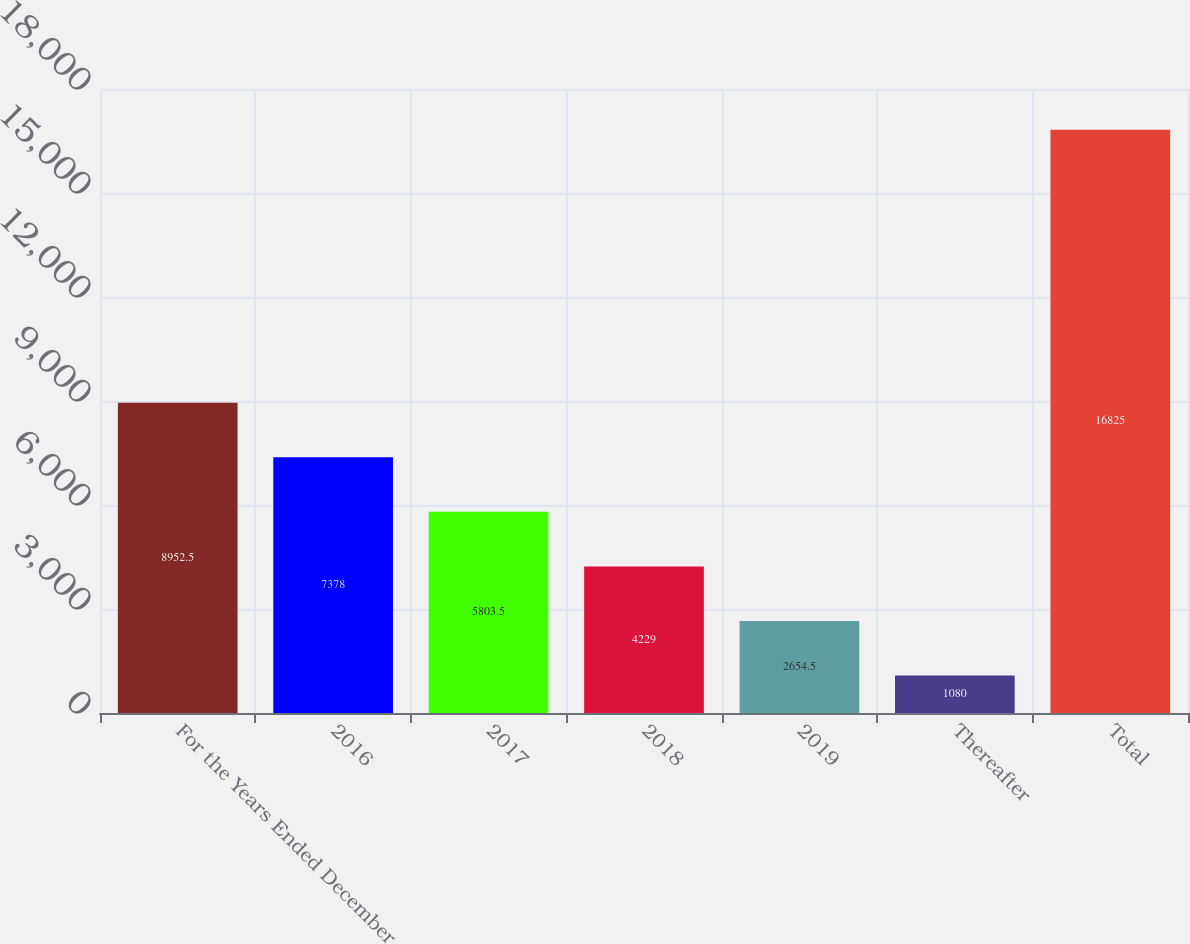<chart> <loc_0><loc_0><loc_500><loc_500><bar_chart><fcel>For the Years Ended December<fcel>2016<fcel>2017<fcel>2018<fcel>2019<fcel>Thereafter<fcel>Total<nl><fcel>8952.5<fcel>7378<fcel>5803.5<fcel>4229<fcel>2654.5<fcel>1080<fcel>16825<nl></chart> 